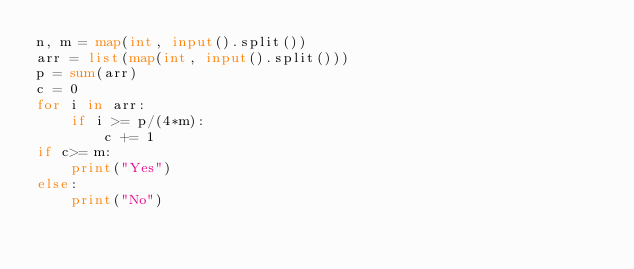<code> <loc_0><loc_0><loc_500><loc_500><_Python_>n, m = map(int, input().split())
arr = list(map(int, input().split()))
p = sum(arr)
c = 0
for i in arr:
    if i >= p/(4*m):
        c += 1
if c>= m:
    print("Yes")
else:
    print("No")
</code> 